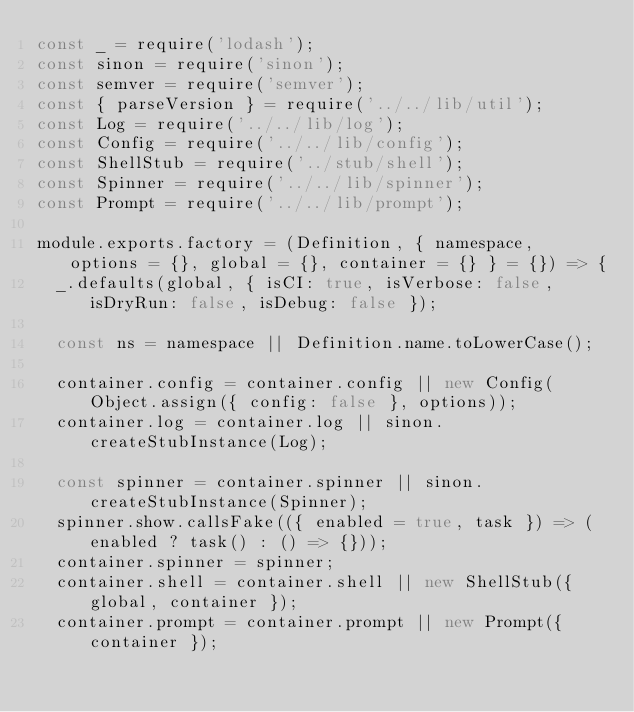Convert code to text. <code><loc_0><loc_0><loc_500><loc_500><_JavaScript_>const _ = require('lodash');
const sinon = require('sinon');
const semver = require('semver');
const { parseVersion } = require('../../lib/util');
const Log = require('../../lib/log');
const Config = require('../../lib/config');
const ShellStub = require('../stub/shell');
const Spinner = require('../../lib/spinner');
const Prompt = require('../../lib/prompt');

module.exports.factory = (Definition, { namespace, options = {}, global = {}, container = {} } = {}) => {
  _.defaults(global, { isCI: true, isVerbose: false, isDryRun: false, isDebug: false });

  const ns = namespace || Definition.name.toLowerCase();

  container.config = container.config || new Config(Object.assign({ config: false }, options));
  container.log = container.log || sinon.createStubInstance(Log);

  const spinner = container.spinner || sinon.createStubInstance(Spinner);
  spinner.show.callsFake(({ enabled = true, task }) => (enabled ? task() : () => {}));
  container.spinner = spinner;
  container.shell = container.shell || new ShellStub({ global, container });
  container.prompt = container.prompt || new Prompt({ container });</code> 